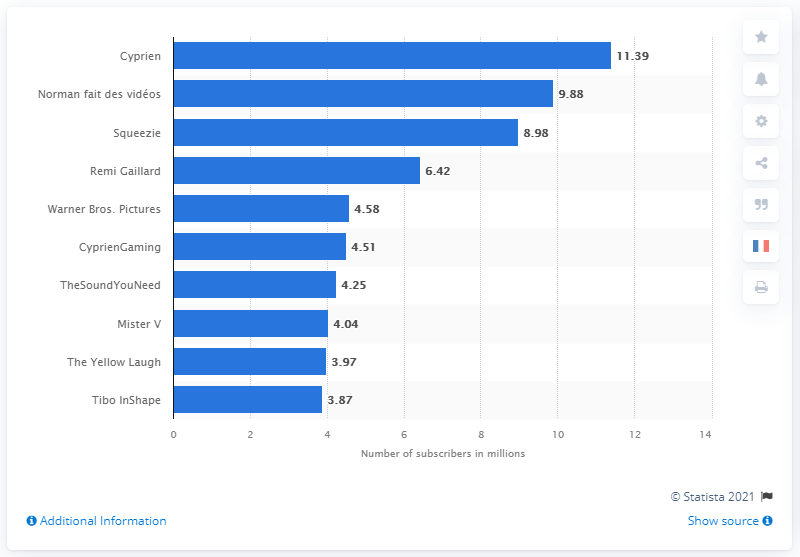Give some essential details in this illustration. In October 2017, Cyprien had 11,390 subscribers. Norman has 9.88 followers on his video channel. 